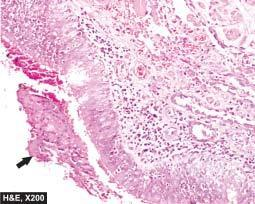what is thickened and infiltrated by acute and chronic inflammatory cells?
Answer the question using a single word or phrase. Bronchial wall 